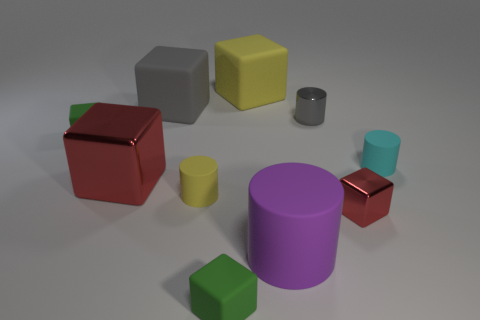Subtract all yellow blocks. How many blocks are left? 5 Subtract all big gray rubber cubes. How many cubes are left? 5 Subtract all purple cubes. Subtract all gray balls. How many cubes are left? 6 Subtract all cubes. How many objects are left? 4 Subtract 0 yellow balls. How many objects are left? 10 Subtract all big gray cylinders. Subtract all small red objects. How many objects are left? 9 Add 9 large gray rubber objects. How many large gray rubber objects are left? 10 Add 1 tiny blue balls. How many tiny blue balls exist? 1 